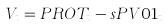<formula> <loc_0><loc_0><loc_500><loc_500>V _ { t } = P R O T _ { t } - s P V 0 1 _ { t }</formula> 